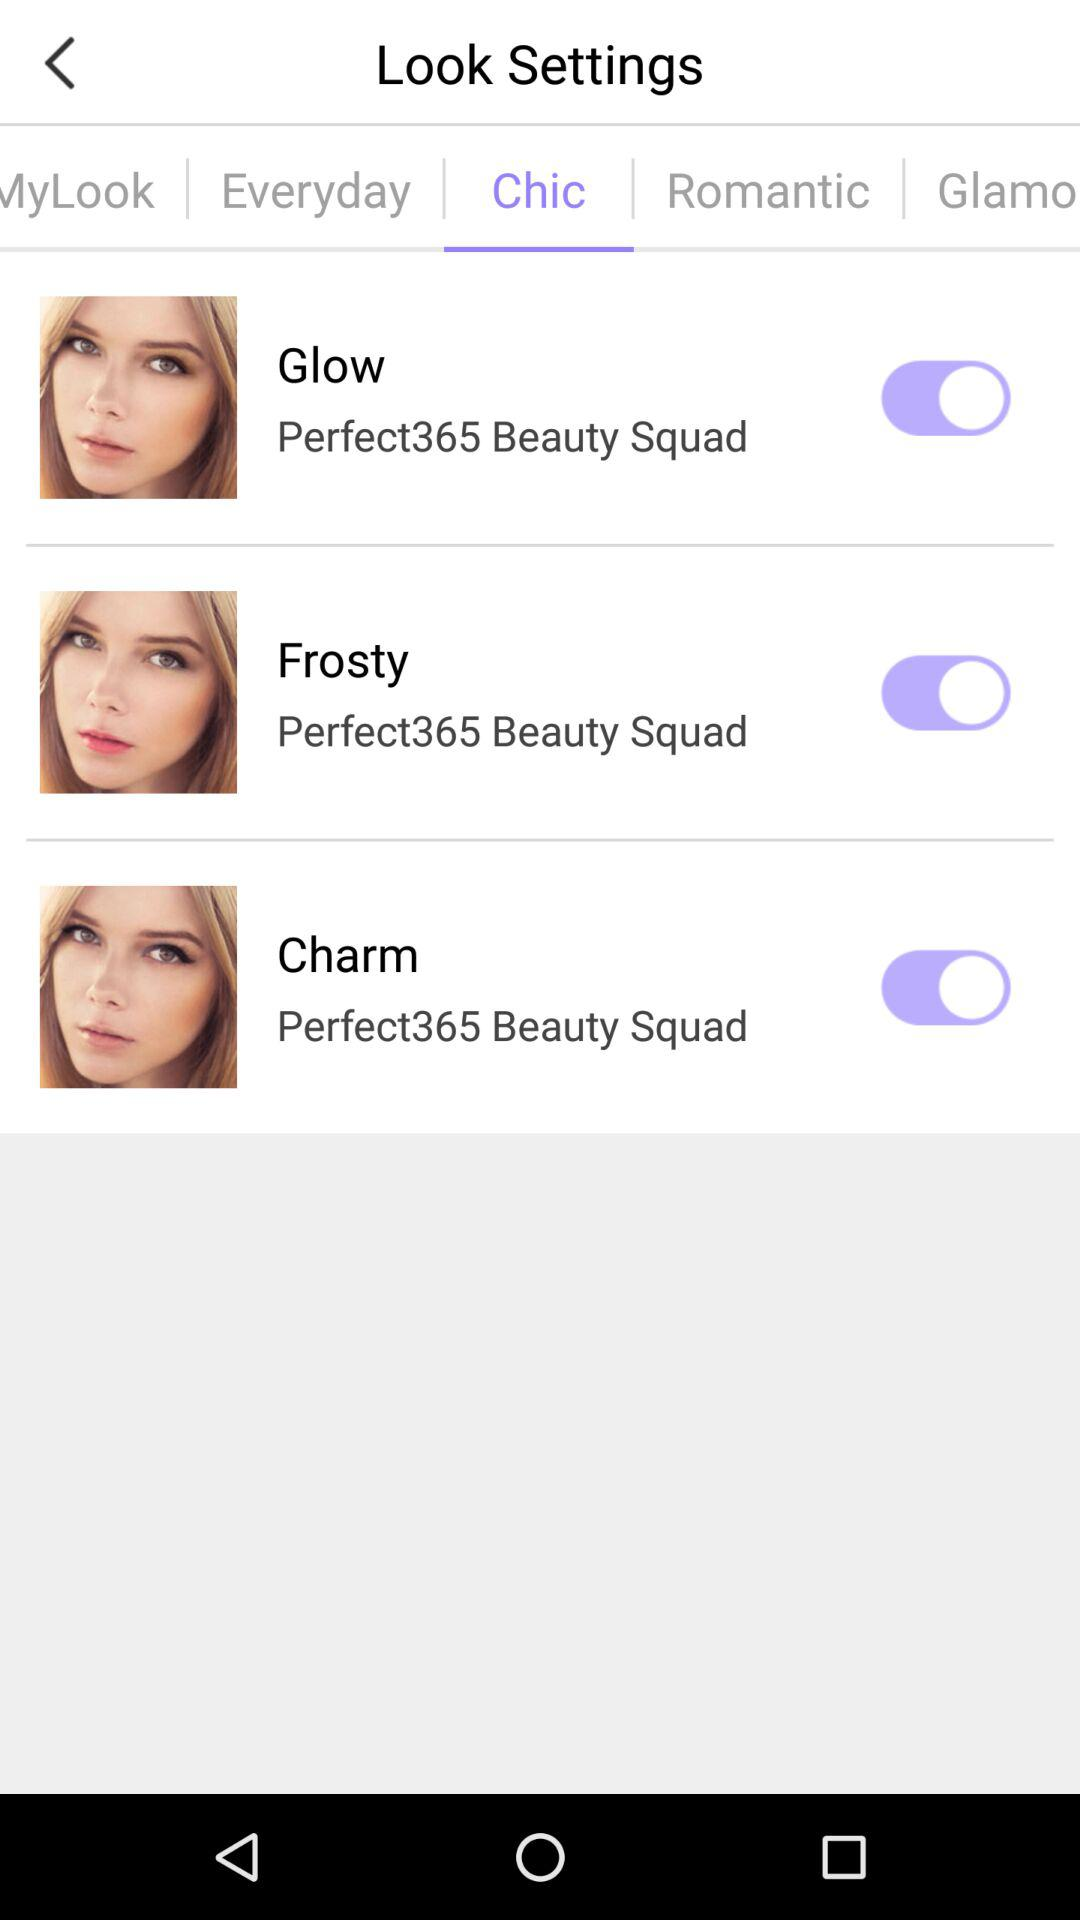Which tab has been selected? The selected tab is "Chic". 